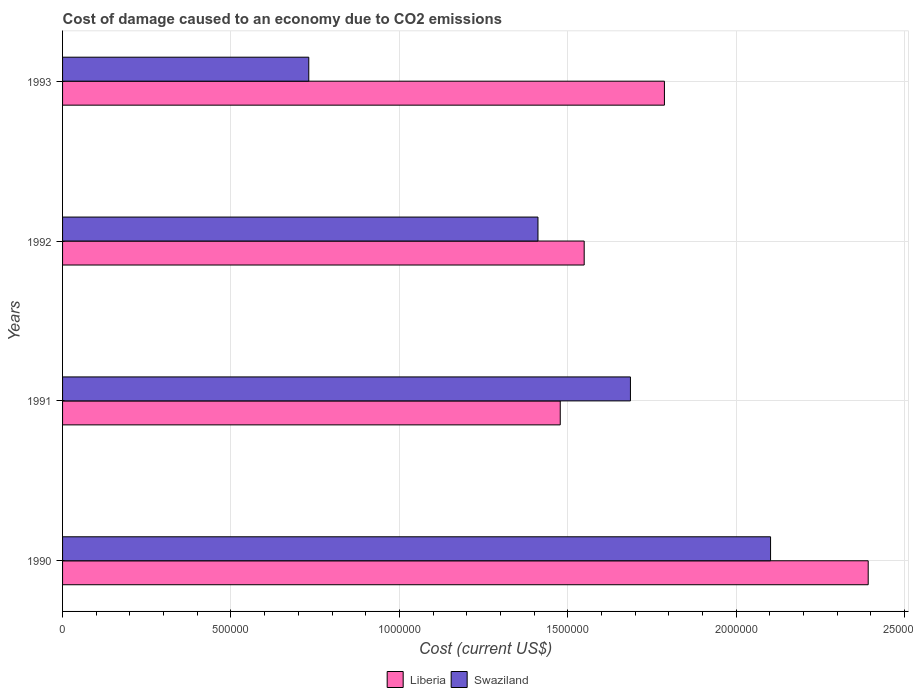How many groups of bars are there?
Provide a short and direct response. 4. Are the number of bars per tick equal to the number of legend labels?
Your answer should be compact. Yes. How many bars are there on the 2nd tick from the top?
Keep it short and to the point. 2. In how many cases, is the number of bars for a given year not equal to the number of legend labels?
Keep it short and to the point. 0. What is the cost of damage caused due to CO2 emissisons in Swaziland in 1990?
Give a very brief answer. 2.10e+06. Across all years, what is the maximum cost of damage caused due to CO2 emissisons in Swaziland?
Ensure brevity in your answer.  2.10e+06. Across all years, what is the minimum cost of damage caused due to CO2 emissisons in Liberia?
Keep it short and to the point. 1.48e+06. In which year was the cost of damage caused due to CO2 emissisons in Swaziland maximum?
Make the answer very short. 1990. What is the total cost of damage caused due to CO2 emissisons in Liberia in the graph?
Your response must be concise. 7.20e+06. What is the difference between the cost of damage caused due to CO2 emissisons in Liberia in 1990 and that in 1993?
Ensure brevity in your answer.  6.05e+05. What is the difference between the cost of damage caused due to CO2 emissisons in Swaziland in 1993 and the cost of damage caused due to CO2 emissisons in Liberia in 1991?
Offer a very short reply. -7.47e+05. What is the average cost of damage caused due to CO2 emissisons in Swaziland per year?
Provide a short and direct response. 1.48e+06. In the year 1990, what is the difference between the cost of damage caused due to CO2 emissisons in Liberia and cost of damage caused due to CO2 emissisons in Swaziland?
Provide a short and direct response. 2.90e+05. What is the ratio of the cost of damage caused due to CO2 emissisons in Swaziland in 1991 to that in 1992?
Ensure brevity in your answer.  1.19. Is the cost of damage caused due to CO2 emissisons in Liberia in 1990 less than that in 1993?
Your answer should be compact. No. Is the difference between the cost of damage caused due to CO2 emissisons in Liberia in 1990 and 1992 greater than the difference between the cost of damage caused due to CO2 emissisons in Swaziland in 1990 and 1992?
Your answer should be very brief. Yes. What is the difference between the highest and the second highest cost of damage caused due to CO2 emissisons in Liberia?
Give a very brief answer. 6.05e+05. What is the difference between the highest and the lowest cost of damage caused due to CO2 emissisons in Swaziland?
Provide a succinct answer. 1.37e+06. In how many years, is the cost of damage caused due to CO2 emissisons in Swaziland greater than the average cost of damage caused due to CO2 emissisons in Swaziland taken over all years?
Offer a very short reply. 2. What does the 2nd bar from the top in 1992 represents?
Your answer should be compact. Liberia. What does the 1st bar from the bottom in 1990 represents?
Offer a very short reply. Liberia. How many bars are there?
Your response must be concise. 8. How many years are there in the graph?
Provide a short and direct response. 4. How many legend labels are there?
Ensure brevity in your answer.  2. What is the title of the graph?
Ensure brevity in your answer.  Cost of damage caused to an economy due to CO2 emissions. Does "Luxembourg" appear as one of the legend labels in the graph?
Offer a very short reply. No. What is the label or title of the X-axis?
Your response must be concise. Cost (current US$). What is the Cost (current US$) in Liberia in 1990?
Offer a terse response. 2.39e+06. What is the Cost (current US$) of Swaziland in 1990?
Your response must be concise. 2.10e+06. What is the Cost (current US$) in Liberia in 1991?
Your answer should be very brief. 1.48e+06. What is the Cost (current US$) of Swaziland in 1991?
Keep it short and to the point. 1.69e+06. What is the Cost (current US$) in Liberia in 1992?
Your answer should be very brief. 1.55e+06. What is the Cost (current US$) of Swaziland in 1992?
Offer a terse response. 1.41e+06. What is the Cost (current US$) in Liberia in 1993?
Your answer should be very brief. 1.79e+06. What is the Cost (current US$) in Swaziland in 1993?
Keep it short and to the point. 7.31e+05. Across all years, what is the maximum Cost (current US$) of Liberia?
Give a very brief answer. 2.39e+06. Across all years, what is the maximum Cost (current US$) in Swaziland?
Make the answer very short. 2.10e+06. Across all years, what is the minimum Cost (current US$) of Liberia?
Ensure brevity in your answer.  1.48e+06. Across all years, what is the minimum Cost (current US$) in Swaziland?
Provide a short and direct response. 7.31e+05. What is the total Cost (current US$) in Liberia in the graph?
Give a very brief answer. 7.20e+06. What is the total Cost (current US$) in Swaziland in the graph?
Give a very brief answer. 5.93e+06. What is the difference between the Cost (current US$) in Liberia in 1990 and that in 1991?
Your answer should be compact. 9.14e+05. What is the difference between the Cost (current US$) of Swaziland in 1990 and that in 1991?
Provide a short and direct response. 4.16e+05. What is the difference between the Cost (current US$) of Liberia in 1990 and that in 1992?
Give a very brief answer. 8.43e+05. What is the difference between the Cost (current US$) in Swaziland in 1990 and that in 1992?
Ensure brevity in your answer.  6.91e+05. What is the difference between the Cost (current US$) of Liberia in 1990 and that in 1993?
Keep it short and to the point. 6.05e+05. What is the difference between the Cost (current US$) of Swaziland in 1990 and that in 1993?
Offer a very short reply. 1.37e+06. What is the difference between the Cost (current US$) in Liberia in 1991 and that in 1992?
Offer a very short reply. -7.10e+04. What is the difference between the Cost (current US$) in Swaziland in 1991 and that in 1992?
Offer a very short reply. 2.75e+05. What is the difference between the Cost (current US$) in Liberia in 1991 and that in 1993?
Offer a terse response. -3.09e+05. What is the difference between the Cost (current US$) of Swaziland in 1991 and that in 1993?
Provide a succinct answer. 9.55e+05. What is the difference between the Cost (current US$) of Liberia in 1992 and that in 1993?
Your answer should be very brief. -2.38e+05. What is the difference between the Cost (current US$) of Swaziland in 1992 and that in 1993?
Keep it short and to the point. 6.80e+05. What is the difference between the Cost (current US$) in Liberia in 1990 and the Cost (current US$) in Swaziland in 1991?
Ensure brevity in your answer.  7.06e+05. What is the difference between the Cost (current US$) of Liberia in 1990 and the Cost (current US$) of Swaziland in 1992?
Keep it short and to the point. 9.80e+05. What is the difference between the Cost (current US$) in Liberia in 1990 and the Cost (current US$) in Swaziland in 1993?
Your answer should be compact. 1.66e+06. What is the difference between the Cost (current US$) of Liberia in 1991 and the Cost (current US$) of Swaziland in 1992?
Offer a terse response. 6.62e+04. What is the difference between the Cost (current US$) in Liberia in 1991 and the Cost (current US$) in Swaziland in 1993?
Give a very brief answer. 7.47e+05. What is the difference between the Cost (current US$) in Liberia in 1992 and the Cost (current US$) in Swaziland in 1993?
Offer a terse response. 8.18e+05. What is the average Cost (current US$) of Liberia per year?
Make the answer very short. 1.80e+06. What is the average Cost (current US$) of Swaziland per year?
Your answer should be compact. 1.48e+06. In the year 1990, what is the difference between the Cost (current US$) of Liberia and Cost (current US$) of Swaziland?
Ensure brevity in your answer.  2.90e+05. In the year 1991, what is the difference between the Cost (current US$) of Liberia and Cost (current US$) of Swaziland?
Ensure brevity in your answer.  -2.08e+05. In the year 1992, what is the difference between the Cost (current US$) in Liberia and Cost (current US$) in Swaziland?
Keep it short and to the point. 1.37e+05. In the year 1993, what is the difference between the Cost (current US$) of Liberia and Cost (current US$) of Swaziland?
Your answer should be very brief. 1.06e+06. What is the ratio of the Cost (current US$) in Liberia in 1990 to that in 1991?
Ensure brevity in your answer.  1.62. What is the ratio of the Cost (current US$) in Swaziland in 1990 to that in 1991?
Make the answer very short. 1.25. What is the ratio of the Cost (current US$) in Liberia in 1990 to that in 1992?
Offer a very short reply. 1.54. What is the ratio of the Cost (current US$) in Swaziland in 1990 to that in 1992?
Offer a very short reply. 1.49. What is the ratio of the Cost (current US$) in Liberia in 1990 to that in 1993?
Provide a succinct answer. 1.34. What is the ratio of the Cost (current US$) of Swaziland in 1990 to that in 1993?
Give a very brief answer. 2.88. What is the ratio of the Cost (current US$) in Liberia in 1991 to that in 1992?
Offer a terse response. 0.95. What is the ratio of the Cost (current US$) in Swaziland in 1991 to that in 1992?
Your response must be concise. 1.19. What is the ratio of the Cost (current US$) of Liberia in 1991 to that in 1993?
Your answer should be very brief. 0.83. What is the ratio of the Cost (current US$) of Swaziland in 1991 to that in 1993?
Your answer should be compact. 2.31. What is the ratio of the Cost (current US$) in Liberia in 1992 to that in 1993?
Provide a short and direct response. 0.87. What is the ratio of the Cost (current US$) in Swaziland in 1992 to that in 1993?
Make the answer very short. 1.93. What is the difference between the highest and the second highest Cost (current US$) of Liberia?
Make the answer very short. 6.05e+05. What is the difference between the highest and the second highest Cost (current US$) of Swaziland?
Your answer should be very brief. 4.16e+05. What is the difference between the highest and the lowest Cost (current US$) of Liberia?
Make the answer very short. 9.14e+05. What is the difference between the highest and the lowest Cost (current US$) of Swaziland?
Your response must be concise. 1.37e+06. 